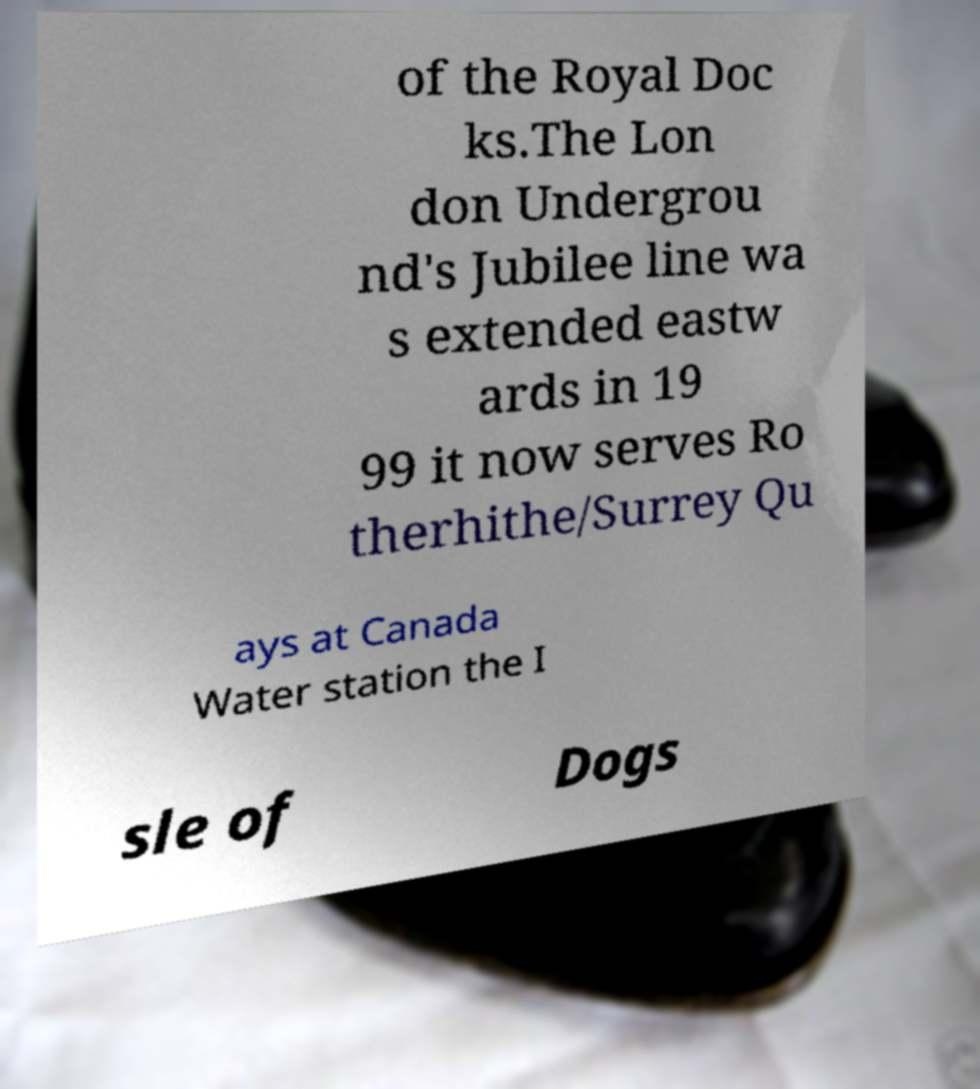What messages or text are displayed in this image? I need them in a readable, typed format. of the Royal Doc ks.The Lon don Undergrou nd's Jubilee line wa s extended eastw ards in 19 99 it now serves Ro therhithe/Surrey Qu ays at Canada Water station the I sle of Dogs 